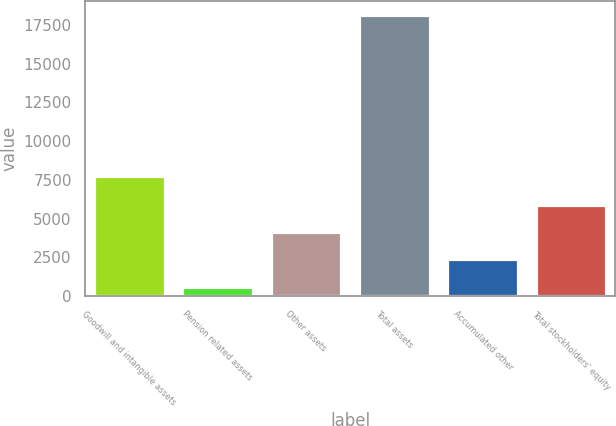<chart> <loc_0><loc_0><loc_500><loc_500><bar_chart><fcel>Goodwill and intangible assets<fcel>Pension related assets<fcel>Other assets<fcel>Total assets<fcel>Accumulated other<fcel>Total stockholders' equity<nl><fcel>7775<fcel>613<fcel>4117.8<fcel>18137<fcel>2365.4<fcel>5870.2<nl></chart> 